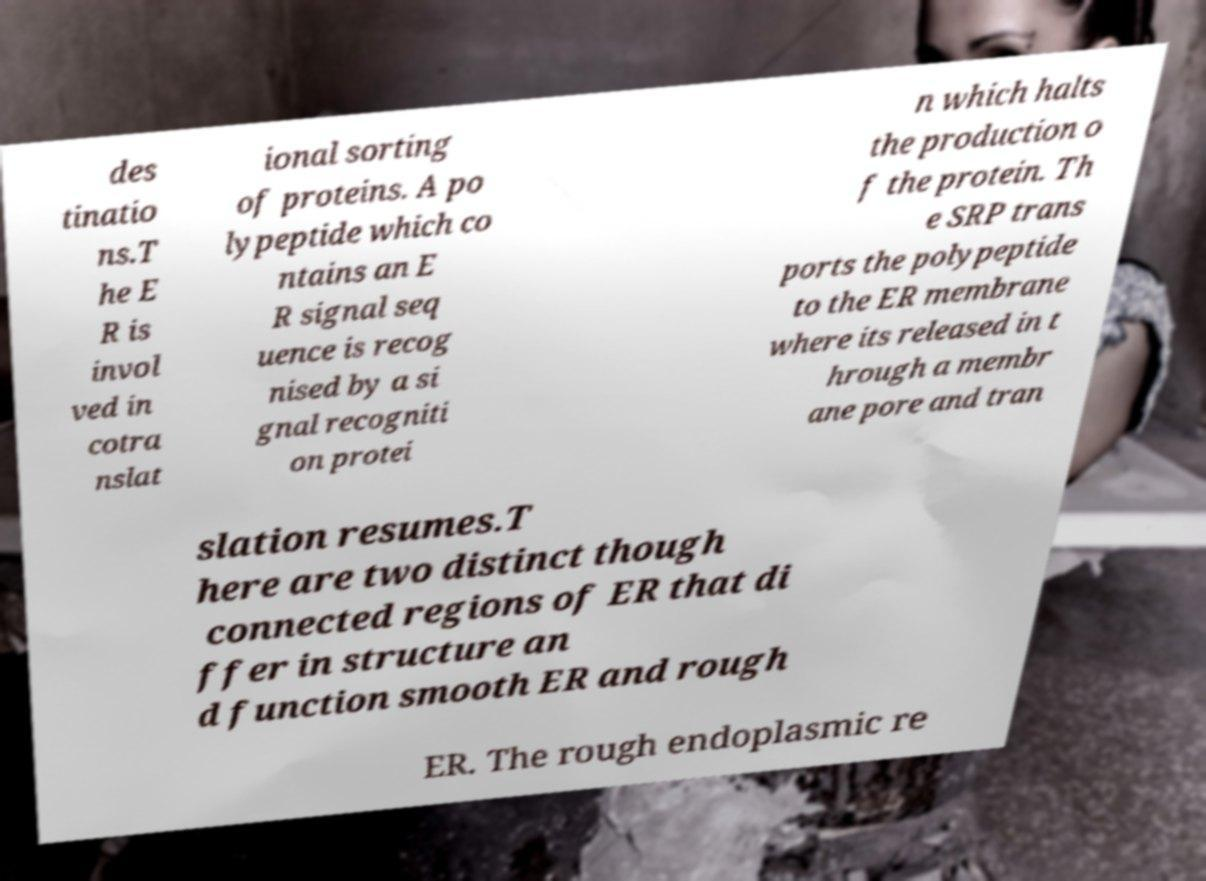Could you extract and type out the text from this image? des tinatio ns.T he E R is invol ved in cotra nslat ional sorting of proteins. A po lypeptide which co ntains an E R signal seq uence is recog nised by a si gnal recogniti on protei n which halts the production o f the protein. Th e SRP trans ports the polypeptide to the ER membrane where its released in t hrough a membr ane pore and tran slation resumes.T here are two distinct though connected regions of ER that di ffer in structure an d function smooth ER and rough ER. The rough endoplasmic re 